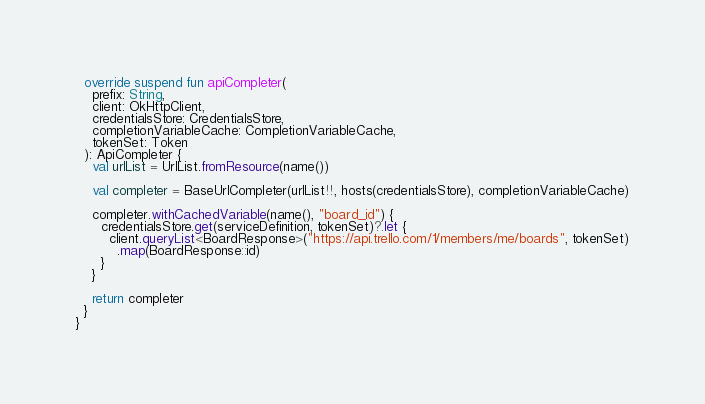<code> <loc_0><loc_0><loc_500><loc_500><_Kotlin_>  override suspend fun apiCompleter(
    prefix: String,
    client: OkHttpClient,
    credentialsStore: CredentialsStore,
    completionVariableCache: CompletionVariableCache,
    tokenSet: Token
  ): ApiCompleter {
    val urlList = UrlList.fromResource(name())

    val completer = BaseUrlCompleter(urlList!!, hosts(credentialsStore), completionVariableCache)

    completer.withCachedVariable(name(), "board_id") {
      credentialsStore.get(serviceDefinition, tokenSet)?.let {
        client.queryList<BoardResponse>("https://api.trello.com/1/members/me/boards", tokenSet)
          .map(BoardResponse::id)
      }
    }

    return completer
  }
}
</code> 